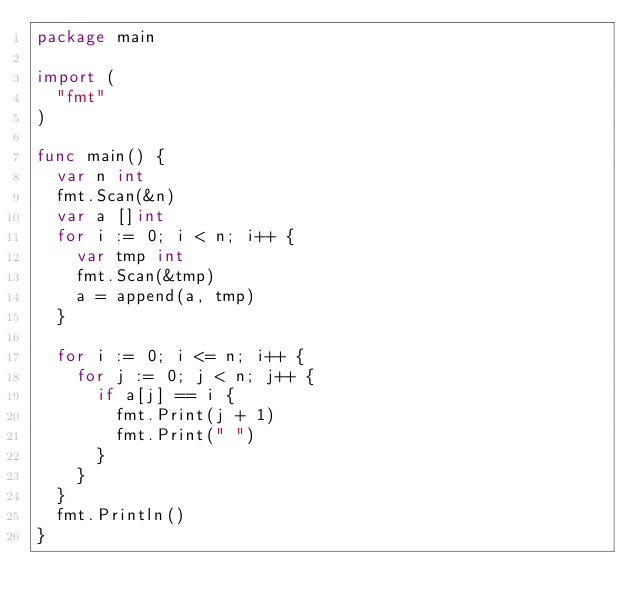<code> <loc_0><loc_0><loc_500><loc_500><_Go_>package main

import (
	"fmt"
)

func main() {
	var n int
	fmt.Scan(&n)
	var a []int
	for i := 0; i < n; i++ {
		var tmp int
		fmt.Scan(&tmp)
		a = append(a, tmp)
	}

	for i := 0; i <= n; i++ {
		for j := 0; j < n; j++ {
			if a[j] == i {
				fmt.Print(j + 1)
				fmt.Print(" ")
			}
		}
	}
	fmt.Println()
}
</code> 